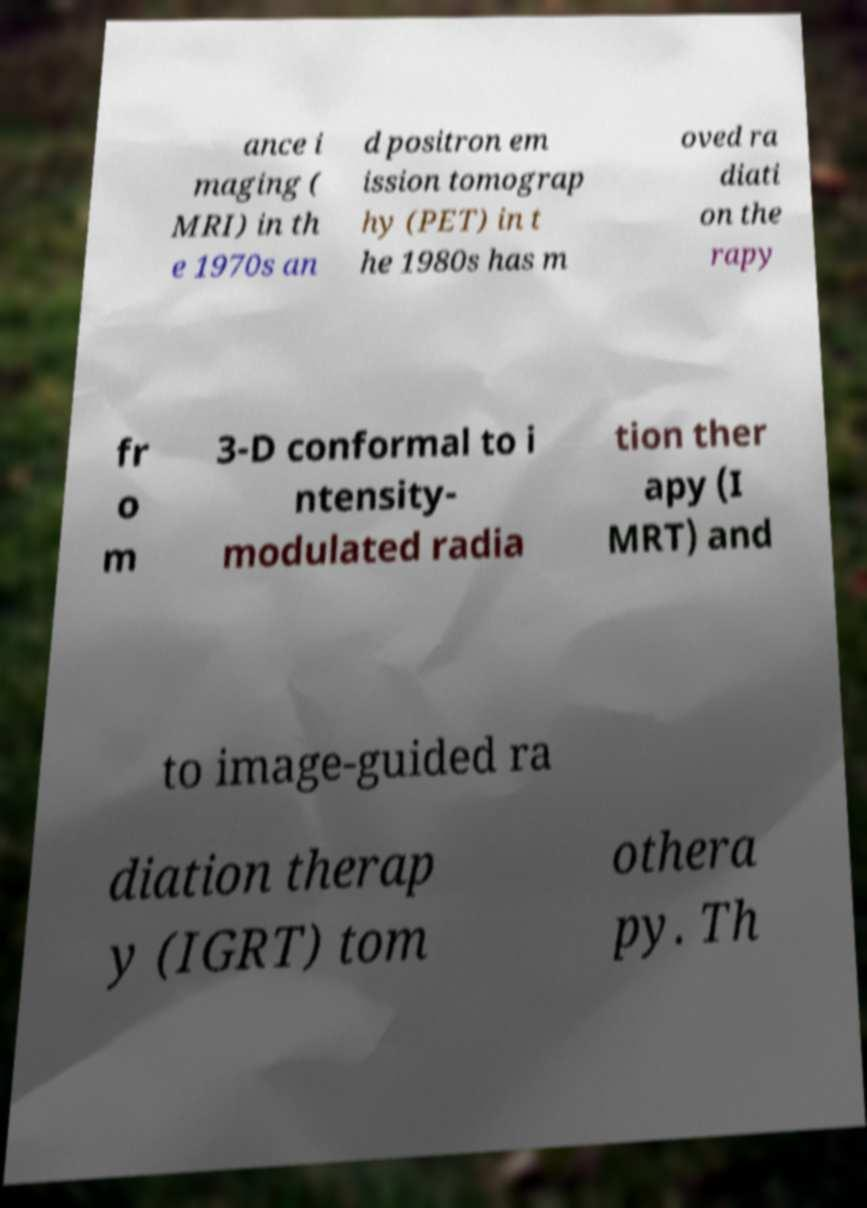Can you accurately transcribe the text from the provided image for me? ance i maging ( MRI) in th e 1970s an d positron em ission tomograp hy (PET) in t he 1980s has m oved ra diati on the rapy fr o m 3-D conformal to i ntensity- modulated radia tion ther apy (I MRT) and to image-guided ra diation therap y (IGRT) tom othera py. Th 